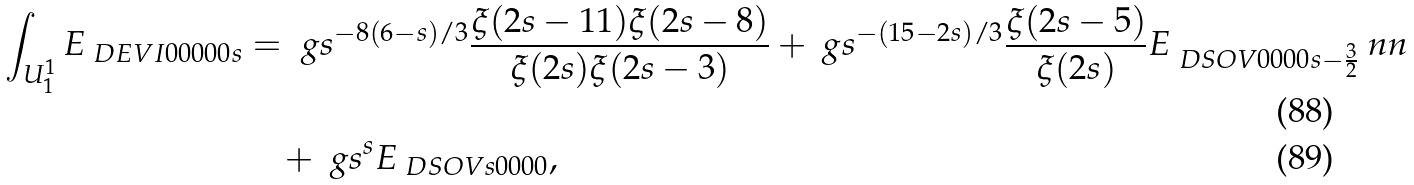<formula> <loc_0><loc_0><loc_500><loc_500>\int _ { U ^ { 1 } _ { 1 } } E _ { \ D E V I { 0 } { 0 } { 0 } { 0 } { 0 } { s } } & = \ g s ^ { - 8 ( 6 - s ) / 3 } \frac { \xi ( 2 s - 1 1 ) \xi ( 2 s - 8 ) } { \xi ( 2 s ) \xi ( 2 s - 3 ) } + \ g s ^ { - ( 1 5 - 2 s ) / 3 } \frac { \xi ( 2 s - 5 ) } { \xi ( 2 s ) } E _ { \ D S O V { 0 } { 0 } { 0 } { 0 } { s - \frac { 3 } { 2 } } } \ n n \\ & \quad + \ g s ^ { s } E _ { \ D S O V { s } { 0 } { 0 } { 0 } { 0 } } ,</formula> 